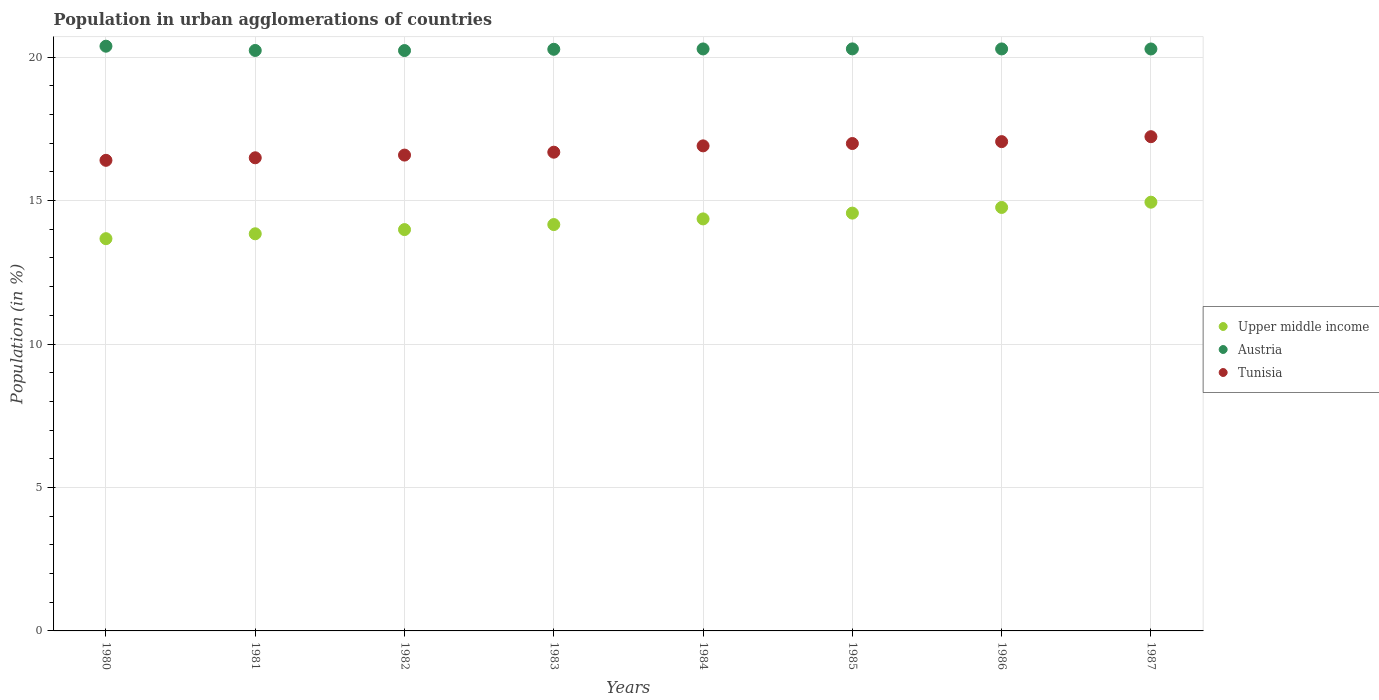Is the number of dotlines equal to the number of legend labels?
Provide a succinct answer. Yes. What is the percentage of population in urban agglomerations in Tunisia in 1986?
Ensure brevity in your answer.  17.06. Across all years, what is the maximum percentage of population in urban agglomerations in Upper middle income?
Provide a succinct answer. 14.95. Across all years, what is the minimum percentage of population in urban agglomerations in Austria?
Your response must be concise. 20.23. In which year was the percentage of population in urban agglomerations in Upper middle income minimum?
Offer a terse response. 1980. What is the total percentage of population in urban agglomerations in Upper middle income in the graph?
Provide a short and direct response. 114.31. What is the difference between the percentage of population in urban agglomerations in Tunisia in 1985 and that in 1986?
Make the answer very short. -0.07. What is the difference between the percentage of population in urban agglomerations in Tunisia in 1985 and the percentage of population in urban agglomerations in Upper middle income in 1981?
Provide a succinct answer. 3.15. What is the average percentage of population in urban agglomerations in Tunisia per year?
Give a very brief answer. 16.79. In the year 1985, what is the difference between the percentage of population in urban agglomerations in Austria and percentage of population in urban agglomerations in Tunisia?
Ensure brevity in your answer.  3.3. What is the ratio of the percentage of population in urban agglomerations in Tunisia in 1981 to that in 1985?
Your answer should be compact. 0.97. What is the difference between the highest and the second highest percentage of population in urban agglomerations in Austria?
Make the answer very short. 0.09. What is the difference between the highest and the lowest percentage of population in urban agglomerations in Upper middle income?
Make the answer very short. 1.27. Does the percentage of population in urban agglomerations in Tunisia monotonically increase over the years?
Provide a short and direct response. Yes. How many dotlines are there?
Offer a very short reply. 3. How many years are there in the graph?
Provide a succinct answer. 8. Are the values on the major ticks of Y-axis written in scientific E-notation?
Provide a short and direct response. No. Does the graph contain grids?
Give a very brief answer. Yes. How are the legend labels stacked?
Offer a terse response. Vertical. What is the title of the graph?
Provide a succinct answer. Population in urban agglomerations of countries. What is the Population (in %) in Upper middle income in 1980?
Your answer should be compact. 13.67. What is the Population (in %) of Austria in 1980?
Your response must be concise. 20.38. What is the Population (in %) in Tunisia in 1980?
Make the answer very short. 16.4. What is the Population (in %) of Upper middle income in 1981?
Make the answer very short. 13.84. What is the Population (in %) in Austria in 1981?
Offer a terse response. 20.23. What is the Population (in %) of Tunisia in 1981?
Offer a very short reply. 16.49. What is the Population (in %) in Upper middle income in 1982?
Offer a terse response. 13.99. What is the Population (in %) of Austria in 1982?
Your answer should be very brief. 20.23. What is the Population (in %) of Tunisia in 1982?
Provide a succinct answer. 16.59. What is the Population (in %) in Upper middle income in 1983?
Your response must be concise. 14.17. What is the Population (in %) of Austria in 1983?
Make the answer very short. 20.27. What is the Population (in %) in Tunisia in 1983?
Offer a very short reply. 16.69. What is the Population (in %) in Upper middle income in 1984?
Your response must be concise. 14.36. What is the Population (in %) of Austria in 1984?
Your response must be concise. 20.29. What is the Population (in %) of Tunisia in 1984?
Keep it short and to the point. 16.91. What is the Population (in %) of Upper middle income in 1985?
Your answer should be very brief. 14.56. What is the Population (in %) of Austria in 1985?
Provide a succinct answer. 20.29. What is the Population (in %) in Tunisia in 1985?
Provide a short and direct response. 16.99. What is the Population (in %) in Upper middle income in 1986?
Your answer should be very brief. 14.76. What is the Population (in %) in Austria in 1986?
Your response must be concise. 20.29. What is the Population (in %) of Tunisia in 1986?
Offer a very short reply. 17.06. What is the Population (in %) of Upper middle income in 1987?
Offer a very short reply. 14.95. What is the Population (in %) in Austria in 1987?
Provide a succinct answer. 20.29. What is the Population (in %) of Tunisia in 1987?
Provide a succinct answer. 17.23. Across all years, what is the maximum Population (in %) of Upper middle income?
Offer a terse response. 14.95. Across all years, what is the maximum Population (in %) of Austria?
Keep it short and to the point. 20.38. Across all years, what is the maximum Population (in %) of Tunisia?
Your response must be concise. 17.23. Across all years, what is the minimum Population (in %) of Upper middle income?
Keep it short and to the point. 13.67. Across all years, what is the minimum Population (in %) in Austria?
Ensure brevity in your answer.  20.23. Across all years, what is the minimum Population (in %) in Tunisia?
Your answer should be very brief. 16.4. What is the total Population (in %) of Upper middle income in the graph?
Your answer should be very brief. 114.31. What is the total Population (in %) of Austria in the graph?
Provide a short and direct response. 162.27. What is the total Population (in %) in Tunisia in the graph?
Your answer should be compact. 134.35. What is the difference between the Population (in %) in Upper middle income in 1980 and that in 1981?
Offer a very short reply. -0.17. What is the difference between the Population (in %) in Austria in 1980 and that in 1981?
Make the answer very short. 0.15. What is the difference between the Population (in %) in Tunisia in 1980 and that in 1981?
Provide a short and direct response. -0.09. What is the difference between the Population (in %) in Upper middle income in 1980 and that in 1982?
Provide a succinct answer. -0.32. What is the difference between the Population (in %) in Austria in 1980 and that in 1982?
Offer a very short reply. 0.15. What is the difference between the Population (in %) in Tunisia in 1980 and that in 1982?
Give a very brief answer. -0.18. What is the difference between the Population (in %) in Upper middle income in 1980 and that in 1983?
Keep it short and to the point. -0.49. What is the difference between the Population (in %) of Austria in 1980 and that in 1983?
Ensure brevity in your answer.  0.11. What is the difference between the Population (in %) of Tunisia in 1980 and that in 1983?
Your answer should be compact. -0.28. What is the difference between the Population (in %) in Upper middle income in 1980 and that in 1984?
Your answer should be compact. -0.69. What is the difference between the Population (in %) in Austria in 1980 and that in 1984?
Offer a terse response. 0.1. What is the difference between the Population (in %) of Tunisia in 1980 and that in 1984?
Keep it short and to the point. -0.5. What is the difference between the Population (in %) of Upper middle income in 1980 and that in 1985?
Your answer should be compact. -0.89. What is the difference between the Population (in %) of Austria in 1980 and that in 1985?
Your answer should be compact. 0.09. What is the difference between the Population (in %) in Tunisia in 1980 and that in 1985?
Offer a terse response. -0.59. What is the difference between the Population (in %) of Upper middle income in 1980 and that in 1986?
Offer a very short reply. -1.09. What is the difference between the Population (in %) of Austria in 1980 and that in 1986?
Your response must be concise. 0.1. What is the difference between the Population (in %) in Tunisia in 1980 and that in 1986?
Offer a terse response. -0.65. What is the difference between the Population (in %) in Upper middle income in 1980 and that in 1987?
Ensure brevity in your answer.  -1.27. What is the difference between the Population (in %) of Austria in 1980 and that in 1987?
Your answer should be very brief. 0.1. What is the difference between the Population (in %) in Tunisia in 1980 and that in 1987?
Give a very brief answer. -0.82. What is the difference between the Population (in %) of Upper middle income in 1981 and that in 1982?
Your answer should be very brief. -0.15. What is the difference between the Population (in %) in Austria in 1981 and that in 1982?
Keep it short and to the point. 0. What is the difference between the Population (in %) of Tunisia in 1981 and that in 1982?
Give a very brief answer. -0.09. What is the difference between the Population (in %) of Upper middle income in 1981 and that in 1983?
Ensure brevity in your answer.  -0.32. What is the difference between the Population (in %) in Austria in 1981 and that in 1983?
Provide a short and direct response. -0.04. What is the difference between the Population (in %) in Tunisia in 1981 and that in 1983?
Your answer should be compact. -0.2. What is the difference between the Population (in %) of Upper middle income in 1981 and that in 1984?
Offer a very short reply. -0.52. What is the difference between the Population (in %) of Austria in 1981 and that in 1984?
Provide a short and direct response. -0.05. What is the difference between the Population (in %) in Tunisia in 1981 and that in 1984?
Provide a short and direct response. -0.42. What is the difference between the Population (in %) in Upper middle income in 1981 and that in 1985?
Offer a very short reply. -0.72. What is the difference between the Population (in %) in Austria in 1981 and that in 1985?
Ensure brevity in your answer.  -0.05. What is the difference between the Population (in %) in Tunisia in 1981 and that in 1985?
Provide a succinct answer. -0.5. What is the difference between the Population (in %) of Upper middle income in 1981 and that in 1986?
Provide a short and direct response. -0.92. What is the difference between the Population (in %) of Austria in 1981 and that in 1986?
Your response must be concise. -0.05. What is the difference between the Population (in %) in Tunisia in 1981 and that in 1986?
Offer a terse response. -0.56. What is the difference between the Population (in %) in Upper middle income in 1981 and that in 1987?
Ensure brevity in your answer.  -1.1. What is the difference between the Population (in %) in Austria in 1981 and that in 1987?
Give a very brief answer. -0.05. What is the difference between the Population (in %) of Tunisia in 1981 and that in 1987?
Keep it short and to the point. -0.74. What is the difference between the Population (in %) of Upper middle income in 1982 and that in 1983?
Make the answer very short. -0.18. What is the difference between the Population (in %) of Austria in 1982 and that in 1983?
Offer a very short reply. -0.04. What is the difference between the Population (in %) of Tunisia in 1982 and that in 1983?
Keep it short and to the point. -0.1. What is the difference between the Population (in %) of Upper middle income in 1982 and that in 1984?
Ensure brevity in your answer.  -0.37. What is the difference between the Population (in %) of Austria in 1982 and that in 1984?
Give a very brief answer. -0.06. What is the difference between the Population (in %) in Tunisia in 1982 and that in 1984?
Keep it short and to the point. -0.32. What is the difference between the Population (in %) of Upper middle income in 1982 and that in 1985?
Provide a short and direct response. -0.57. What is the difference between the Population (in %) in Austria in 1982 and that in 1985?
Provide a succinct answer. -0.06. What is the difference between the Population (in %) of Tunisia in 1982 and that in 1985?
Make the answer very short. -0.4. What is the difference between the Population (in %) in Upper middle income in 1982 and that in 1986?
Make the answer very short. -0.77. What is the difference between the Population (in %) of Austria in 1982 and that in 1986?
Ensure brevity in your answer.  -0.06. What is the difference between the Population (in %) in Tunisia in 1982 and that in 1986?
Offer a very short reply. -0.47. What is the difference between the Population (in %) in Upper middle income in 1982 and that in 1987?
Make the answer very short. -0.96. What is the difference between the Population (in %) of Austria in 1982 and that in 1987?
Ensure brevity in your answer.  -0.05. What is the difference between the Population (in %) in Tunisia in 1982 and that in 1987?
Give a very brief answer. -0.64. What is the difference between the Population (in %) of Upper middle income in 1983 and that in 1984?
Offer a terse response. -0.2. What is the difference between the Population (in %) in Austria in 1983 and that in 1984?
Provide a succinct answer. -0.01. What is the difference between the Population (in %) in Tunisia in 1983 and that in 1984?
Keep it short and to the point. -0.22. What is the difference between the Population (in %) of Upper middle income in 1983 and that in 1985?
Ensure brevity in your answer.  -0.4. What is the difference between the Population (in %) in Austria in 1983 and that in 1985?
Give a very brief answer. -0.01. What is the difference between the Population (in %) in Tunisia in 1983 and that in 1985?
Offer a very short reply. -0.3. What is the difference between the Population (in %) in Upper middle income in 1983 and that in 1986?
Give a very brief answer. -0.6. What is the difference between the Population (in %) in Austria in 1983 and that in 1986?
Your answer should be compact. -0.01. What is the difference between the Population (in %) in Tunisia in 1983 and that in 1986?
Give a very brief answer. -0.37. What is the difference between the Population (in %) in Upper middle income in 1983 and that in 1987?
Provide a short and direct response. -0.78. What is the difference between the Population (in %) of Austria in 1983 and that in 1987?
Ensure brevity in your answer.  -0.01. What is the difference between the Population (in %) in Tunisia in 1983 and that in 1987?
Make the answer very short. -0.54. What is the difference between the Population (in %) in Upper middle income in 1984 and that in 1985?
Your answer should be compact. -0.2. What is the difference between the Population (in %) in Austria in 1984 and that in 1985?
Offer a terse response. -0. What is the difference between the Population (in %) of Tunisia in 1984 and that in 1985?
Make the answer very short. -0.08. What is the difference between the Population (in %) of Upper middle income in 1984 and that in 1986?
Keep it short and to the point. -0.4. What is the difference between the Population (in %) of Austria in 1984 and that in 1986?
Your answer should be very brief. -0. What is the difference between the Population (in %) in Tunisia in 1984 and that in 1986?
Provide a succinct answer. -0.15. What is the difference between the Population (in %) of Upper middle income in 1984 and that in 1987?
Offer a very short reply. -0.58. What is the difference between the Population (in %) of Austria in 1984 and that in 1987?
Give a very brief answer. 0. What is the difference between the Population (in %) of Tunisia in 1984 and that in 1987?
Provide a succinct answer. -0.32. What is the difference between the Population (in %) in Upper middle income in 1985 and that in 1986?
Offer a very short reply. -0.2. What is the difference between the Population (in %) of Austria in 1985 and that in 1986?
Keep it short and to the point. 0. What is the difference between the Population (in %) in Tunisia in 1985 and that in 1986?
Your answer should be very brief. -0.07. What is the difference between the Population (in %) in Upper middle income in 1985 and that in 1987?
Give a very brief answer. -0.38. What is the difference between the Population (in %) in Austria in 1985 and that in 1987?
Make the answer very short. 0. What is the difference between the Population (in %) of Tunisia in 1985 and that in 1987?
Keep it short and to the point. -0.24. What is the difference between the Population (in %) in Upper middle income in 1986 and that in 1987?
Provide a short and direct response. -0.18. What is the difference between the Population (in %) in Austria in 1986 and that in 1987?
Provide a succinct answer. 0. What is the difference between the Population (in %) of Tunisia in 1986 and that in 1987?
Provide a short and direct response. -0.17. What is the difference between the Population (in %) of Upper middle income in 1980 and the Population (in %) of Austria in 1981?
Provide a short and direct response. -6.56. What is the difference between the Population (in %) of Upper middle income in 1980 and the Population (in %) of Tunisia in 1981?
Your answer should be compact. -2.82. What is the difference between the Population (in %) in Austria in 1980 and the Population (in %) in Tunisia in 1981?
Provide a short and direct response. 3.89. What is the difference between the Population (in %) in Upper middle income in 1980 and the Population (in %) in Austria in 1982?
Your answer should be compact. -6.56. What is the difference between the Population (in %) in Upper middle income in 1980 and the Population (in %) in Tunisia in 1982?
Give a very brief answer. -2.91. What is the difference between the Population (in %) in Austria in 1980 and the Population (in %) in Tunisia in 1982?
Provide a succinct answer. 3.8. What is the difference between the Population (in %) in Upper middle income in 1980 and the Population (in %) in Austria in 1983?
Offer a terse response. -6.6. What is the difference between the Population (in %) in Upper middle income in 1980 and the Population (in %) in Tunisia in 1983?
Keep it short and to the point. -3.01. What is the difference between the Population (in %) of Austria in 1980 and the Population (in %) of Tunisia in 1983?
Provide a succinct answer. 3.69. What is the difference between the Population (in %) of Upper middle income in 1980 and the Population (in %) of Austria in 1984?
Your answer should be very brief. -6.61. What is the difference between the Population (in %) of Upper middle income in 1980 and the Population (in %) of Tunisia in 1984?
Offer a very short reply. -3.23. What is the difference between the Population (in %) in Austria in 1980 and the Population (in %) in Tunisia in 1984?
Your answer should be very brief. 3.47. What is the difference between the Population (in %) of Upper middle income in 1980 and the Population (in %) of Austria in 1985?
Give a very brief answer. -6.62. What is the difference between the Population (in %) of Upper middle income in 1980 and the Population (in %) of Tunisia in 1985?
Your response must be concise. -3.32. What is the difference between the Population (in %) in Austria in 1980 and the Population (in %) in Tunisia in 1985?
Your answer should be compact. 3.39. What is the difference between the Population (in %) of Upper middle income in 1980 and the Population (in %) of Austria in 1986?
Your answer should be very brief. -6.61. What is the difference between the Population (in %) in Upper middle income in 1980 and the Population (in %) in Tunisia in 1986?
Offer a terse response. -3.38. What is the difference between the Population (in %) in Austria in 1980 and the Population (in %) in Tunisia in 1986?
Provide a succinct answer. 3.33. What is the difference between the Population (in %) of Upper middle income in 1980 and the Population (in %) of Austria in 1987?
Give a very brief answer. -6.61. What is the difference between the Population (in %) of Upper middle income in 1980 and the Population (in %) of Tunisia in 1987?
Provide a short and direct response. -3.56. What is the difference between the Population (in %) of Austria in 1980 and the Population (in %) of Tunisia in 1987?
Offer a very short reply. 3.15. What is the difference between the Population (in %) of Upper middle income in 1981 and the Population (in %) of Austria in 1982?
Offer a very short reply. -6.39. What is the difference between the Population (in %) of Upper middle income in 1981 and the Population (in %) of Tunisia in 1982?
Provide a short and direct response. -2.74. What is the difference between the Population (in %) of Austria in 1981 and the Population (in %) of Tunisia in 1982?
Your answer should be compact. 3.65. What is the difference between the Population (in %) in Upper middle income in 1981 and the Population (in %) in Austria in 1983?
Give a very brief answer. -6.43. What is the difference between the Population (in %) of Upper middle income in 1981 and the Population (in %) of Tunisia in 1983?
Give a very brief answer. -2.84. What is the difference between the Population (in %) of Austria in 1981 and the Population (in %) of Tunisia in 1983?
Your response must be concise. 3.55. What is the difference between the Population (in %) of Upper middle income in 1981 and the Population (in %) of Austria in 1984?
Ensure brevity in your answer.  -6.44. What is the difference between the Population (in %) in Upper middle income in 1981 and the Population (in %) in Tunisia in 1984?
Provide a succinct answer. -3.06. What is the difference between the Population (in %) of Austria in 1981 and the Population (in %) of Tunisia in 1984?
Keep it short and to the point. 3.33. What is the difference between the Population (in %) in Upper middle income in 1981 and the Population (in %) in Austria in 1985?
Your response must be concise. -6.45. What is the difference between the Population (in %) of Upper middle income in 1981 and the Population (in %) of Tunisia in 1985?
Offer a terse response. -3.15. What is the difference between the Population (in %) of Austria in 1981 and the Population (in %) of Tunisia in 1985?
Your answer should be compact. 3.24. What is the difference between the Population (in %) in Upper middle income in 1981 and the Population (in %) in Austria in 1986?
Keep it short and to the point. -6.44. What is the difference between the Population (in %) of Upper middle income in 1981 and the Population (in %) of Tunisia in 1986?
Offer a terse response. -3.21. What is the difference between the Population (in %) of Austria in 1981 and the Population (in %) of Tunisia in 1986?
Your answer should be very brief. 3.18. What is the difference between the Population (in %) in Upper middle income in 1981 and the Population (in %) in Austria in 1987?
Make the answer very short. -6.44. What is the difference between the Population (in %) in Upper middle income in 1981 and the Population (in %) in Tunisia in 1987?
Your response must be concise. -3.38. What is the difference between the Population (in %) of Austria in 1981 and the Population (in %) of Tunisia in 1987?
Keep it short and to the point. 3.01. What is the difference between the Population (in %) in Upper middle income in 1982 and the Population (in %) in Austria in 1983?
Offer a terse response. -6.28. What is the difference between the Population (in %) in Upper middle income in 1982 and the Population (in %) in Tunisia in 1983?
Your answer should be compact. -2.7. What is the difference between the Population (in %) in Austria in 1982 and the Population (in %) in Tunisia in 1983?
Your answer should be compact. 3.54. What is the difference between the Population (in %) in Upper middle income in 1982 and the Population (in %) in Austria in 1984?
Give a very brief answer. -6.3. What is the difference between the Population (in %) in Upper middle income in 1982 and the Population (in %) in Tunisia in 1984?
Make the answer very short. -2.92. What is the difference between the Population (in %) of Austria in 1982 and the Population (in %) of Tunisia in 1984?
Your response must be concise. 3.32. What is the difference between the Population (in %) in Upper middle income in 1982 and the Population (in %) in Austria in 1985?
Provide a short and direct response. -6.3. What is the difference between the Population (in %) of Upper middle income in 1982 and the Population (in %) of Tunisia in 1985?
Ensure brevity in your answer.  -3. What is the difference between the Population (in %) of Austria in 1982 and the Population (in %) of Tunisia in 1985?
Provide a short and direct response. 3.24. What is the difference between the Population (in %) in Upper middle income in 1982 and the Population (in %) in Austria in 1986?
Offer a very short reply. -6.3. What is the difference between the Population (in %) of Upper middle income in 1982 and the Population (in %) of Tunisia in 1986?
Your answer should be very brief. -3.07. What is the difference between the Population (in %) of Austria in 1982 and the Population (in %) of Tunisia in 1986?
Your answer should be compact. 3.17. What is the difference between the Population (in %) in Upper middle income in 1982 and the Population (in %) in Austria in 1987?
Your answer should be very brief. -6.3. What is the difference between the Population (in %) of Upper middle income in 1982 and the Population (in %) of Tunisia in 1987?
Your answer should be compact. -3.24. What is the difference between the Population (in %) of Austria in 1982 and the Population (in %) of Tunisia in 1987?
Offer a very short reply. 3. What is the difference between the Population (in %) in Upper middle income in 1983 and the Population (in %) in Austria in 1984?
Your answer should be compact. -6.12. What is the difference between the Population (in %) in Upper middle income in 1983 and the Population (in %) in Tunisia in 1984?
Your answer should be compact. -2.74. What is the difference between the Population (in %) of Austria in 1983 and the Population (in %) of Tunisia in 1984?
Make the answer very short. 3.37. What is the difference between the Population (in %) in Upper middle income in 1983 and the Population (in %) in Austria in 1985?
Your answer should be very brief. -6.12. What is the difference between the Population (in %) in Upper middle income in 1983 and the Population (in %) in Tunisia in 1985?
Your response must be concise. -2.83. What is the difference between the Population (in %) of Austria in 1983 and the Population (in %) of Tunisia in 1985?
Keep it short and to the point. 3.28. What is the difference between the Population (in %) in Upper middle income in 1983 and the Population (in %) in Austria in 1986?
Keep it short and to the point. -6.12. What is the difference between the Population (in %) of Upper middle income in 1983 and the Population (in %) of Tunisia in 1986?
Offer a terse response. -2.89. What is the difference between the Population (in %) in Austria in 1983 and the Population (in %) in Tunisia in 1986?
Offer a terse response. 3.22. What is the difference between the Population (in %) in Upper middle income in 1983 and the Population (in %) in Austria in 1987?
Your answer should be very brief. -6.12. What is the difference between the Population (in %) of Upper middle income in 1983 and the Population (in %) of Tunisia in 1987?
Give a very brief answer. -3.06. What is the difference between the Population (in %) in Austria in 1983 and the Population (in %) in Tunisia in 1987?
Provide a short and direct response. 3.05. What is the difference between the Population (in %) of Upper middle income in 1984 and the Population (in %) of Austria in 1985?
Keep it short and to the point. -5.93. What is the difference between the Population (in %) in Upper middle income in 1984 and the Population (in %) in Tunisia in 1985?
Your answer should be very brief. -2.63. What is the difference between the Population (in %) of Austria in 1984 and the Population (in %) of Tunisia in 1985?
Provide a succinct answer. 3.3. What is the difference between the Population (in %) of Upper middle income in 1984 and the Population (in %) of Austria in 1986?
Provide a succinct answer. -5.92. What is the difference between the Population (in %) in Upper middle income in 1984 and the Population (in %) in Tunisia in 1986?
Your answer should be very brief. -2.69. What is the difference between the Population (in %) of Austria in 1984 and the Population (in %) of Tunisia in 1986?
Give a very brief answer. 3.23. What is the difference between the Population (in %) of Upper middle income in 1984 and the Population (in %) of Austria in 1987?
Make the answer very short. -5.92. What is the difference between the Population (in %) of Upper middle income in 1984 and the Population (in %) of Tunisia in 1987?
Make the answer very short. -2.87. What is the difference between the Population (in %) of Austria in 1984 and the Population (in %) of Tunisia in 1987?
Offer a very short reply. 3.06. What is the difference between the Population (in %) of Upper middle income in 1985 and the Population (in %) of Austria in 1986?
Make the answer very short. -5.72. What is the difference between the Population (in %) of Upper middle income in 1985 and the Population (in %) of Tunisia in 1986?
Offer a very short reply. -2.49. What is the difference between the Population (in %) of Austria in 1985 and the Population (in %) of Tunisia in 1986?
Make the answer very short. 3.23. What is the difference between the Population (in %) in Upper middle income in 1985 and the Population (in %) in Austria in 1987?
Your answer should be very brief. -5.72. What is the difference between the Population (in %) of Upper middle income in 1985 and the Population (in %) of Tunisia in 1987?
Provide a succinct answer. -2.66. What is the difference between the Population (in %) in Austria in 1985 and the Population (in %) in Tunisia in 1987?
Make the answer very short. 3.06. What is the difference between the Population (in %) in Upper middle income in 1986 and the Population (in %) in Austria in 1987?
Ensure brevity in your answer.  -5.52. What is the difference between the Population (in %) of Upper middle income in 1986 and the Population (in %) of Tunisia in 1987?
Offer a terse response. -2.47. What is the difference between the Population (in %) in Austria in 1986 and the Population (in %) in Tunisia in 1987?
Offer a very short reply. 3.06. What is the average Population (in %) of Upper middle income per year?
Offer a terse response. 14.29. What is the average Population (in %) of Austria per year?
Provide a short and direct response. 20.28. What is the average Population (in %) of Tunisia per year?
Offer a terse response. 16.79. In the year 1980, what is the difference between the Population (in %) in Upper middle income and Population (in %) in Austria?
Your answer should be compact. -6.71. In the year 1980, what is the difference between the Population (in %) of Upper middle income and Population (in %) of Tunisia?
Keep it short and to the point. -2.73. In the year 1980, what is the difference between the Population (in %) of Austria and Population (in %) of Tunisia?
Provide a short and direct response. 3.98. In the year 1981, what is the difference between the Population (in %) in Upper middle income and Population (in %) in Austria?
Your answer should be very brief. -6.39. In the year 1981, what is the difference between the Population (in %) of Upper middle income and Population (in %) of Tunisia?
Give a very brief answer. -2.65. In the year 1981, what is the difference between the Population (in %) in Austria and Population (in %) in Tunisia?
Give a very brief answer. 3.74. In the year 1982, what is the difference between the Population (in %) in Upper middle income and Population (in %) in Austria?
Make the answer very short. -6.24. In the year 1982, what is the difference between the Population (in %) in Upper middle income and Population (in %) in Tunisia?
Provide a succinct answer. -2.6. In the year 1982, what is the difference between the Population (in %) in Austria and Population (in %) in Tunisia?
Keep it short and to the point. 3.64. In the year 1983, what is the difference between the Population (in %) in Upper middle income and Population (in %) in Austria?
Give a very brief answer. -6.11. In the year 1983, what is the difference between the Population (in %) in Upper middle income and Population (in %) in Tunisia?
Make the answer very short. -2.52. In the year 1983, what is the difference between the Population (in %) of Austria and Population (in %) of Tunisia?
Your response must be concise. 3.59. In the year 1984, what is the difference between the Population (in %) of Upper middle income and Population (in %) of Austria?
Ensure brevity in your answer.  -5.92. In the year 1984, what is the difference between the Population (in %) in Upper middle income and Population (in %) in Tunisia?
Ensure brevity in your answer.  -2.55. In the year 1984, what is the difference between the Population (in %) in Austria and Population (in %) in Tunisia?
Give a very brief answer. 3.38. In the year 1985, what is the difference between the Population (in %) in Upper middle income and Population (in %) in Austria?
Give a very brief answer. -5.72. In the year 1985, what is the difference between the Population (in %) in Upper middle income and Population (in %) in Tunisia?
Offer a terse response. -2.43. In the year 1985, what is the difference between the Population (in %) in Austria and Population (in %) in Tunisia?
Provide a short and direct response. 3.3. In the year 1986, what is the difference between the Population (in %) of Upper middle income and Population (in %) of Austria?
Provide a short and direct response. -5.53. In the year 1986, what is the difference between the Population (in %) of Upper middle income and Population (in %) of Tunisia?
Your response must be concise. -2.29. In the year 1986, what is the difference between the Population (in %) of Austria and Population (in %) of Tunisia?
Ensure brevity in your answer.  3.23. In the year 1987, what is the difference between the Population (in %) of Upper middle income and Population (in %) of Austria?
Provide a short and direct response. -5.34. In the year 1987, what is the difference between the Population (in %) of Upper middle income and Population (in %) of Tunisia?
Offer a very short reply. -2.28. In the year 1987, what is the difference between the Population (in %) in Austria and Population (in %) in Tunisia?
Offer a terse response. 3.06. What is the ratio of the Population (in %) in Upper middle income in 1980 to that in 1981?
Make the answer very short. 0.99. What is the ratio of the Population (in %) in Austria in 1980 to that in 1981?
Your answer should be very brief. 1.01. What is the ratio of the Population (in %) in Upper middle income in 1980 to that in 1982?
Provide a short and direct response. 0.98. What is the ratio of the Population (in %) in Austria in 1980 to that in 1982?
Your answer should be very brief. 1.01. What is the ratio of the Population (in %) in Tunisia in 1980 to that in 1982?
Make the answer very short. 0.99. What is the ratio of the Population (in %) in Upper middle income in 1980 to that in 1983?
Your answer should be very brief. 0.97. What is the ratio of the Population (in %) of Austria in 1980 to that in 1983?
Offer a terse response. 1.01. What is the ratio of the Population (in %) in Tunisia in 1980 to that in 1983?
Ensure brevity in your answer.  0.98. What is the ratio of the Population (in %) of Upper middle income in 1980 to that in 1984?
Provide a short and direct response. 0.95. What is the ratio of the Population (in %) of Tunisia in 1980 to that in 1984?
Offer a terse response. 0.97. What is the ratio of the Population (in %) of Upper middle income in 1980 to that in 1985?
Ensure brevity in your answer.  0.94. What is the ratio of the Population (in %) of Tunisia in 1980 to that in 1985?
Provide a succinct answer. 0.97. What is the ratio of the Population (in %) of Upper middle income in 1980 to that in 1986?
Offer a very short reply. 0.93. What is the ratio of the Population (in %) of Austria in 1980 to that in 1986?
Your response must be concise. 1. What is the ratio of the Population (in %) in Tunisia in 1980 to that in 1986?
Keep it short and to the point. 0.96. What is the ratio of the Population (in %) of Upper middle income in 1980 to that in 1987?
Offer a very short reply. 0.91. What is the ratio of the Population (in %) in Tunisia in 1980 to that in 1987?
Offer a very short reply. 0.95. What is the ratio of the Population (in %) of Austria in 1981 to that in 1982?
Offer a very short reply. 1. What is the ratio of the Population (in %) of Upper middle income in 1981 to that in 1983?
Provide a short and direct response. 0.98. What is the ratio of the Population (in %) in Tunisia in 1981 to that in 1983?
Ensure brevity in your answer.  0.99. What is the ratio of the Population (in %) in Upper middle income in 1981 to that in 1984?
Your answer should be very brief. 0.96. What is the ratio of the Population (in %) in Tunisia in 1981 to that in 1984?
Make the answer very short. 0.98. What is the ratio of the Population (in %) in Upper middle income in 1981 to that in 1985?
Give a very brief answer. 0.95. What is the ratio of the Population (in %) of Austria in 1981 to that in 1985?
Provide a short and direct response. 1. What is the ratio of the Population (in %) of Tunisia in 1981 to that in 1985?
Provide a succinct answer. 0.97. What is the ratio of the Population (in %) of Upper middle income in 1981 to that in 1986?
Give a very brief answer. 0.94. What is the ratio of the Population (in %) of Tunisia in 1981 to that in 1986?
Your answer should be compact. 0.97. What is the ratio of the Population (in %) in Upper middle income in 1981 to that in 1987?
Offer a very short reply. 0.93. What is the ratio of the Population (in %) in Tunisia in 1981 to that in 1987?
Make the answer very short. 0.96. What is the ratio of the Population (in %) of Upper middle income in 1982 to that in 1983?
Offer a terse response. 0.99. What is the ratio of the Population (in %) in Upper middle income in 1982 to that in 1984?
Your response must be concise. 0.97. What is the ratio of the Population (in %) in Tunisia in 1982 to that in 1984?
Ensure brevity in your answer.  0.98. What is the ratio of the Population (in %) of Upper middle income in 1982 to that in 1985?
Your response must be concise. 0.96. What is the ratio of the Population (in %) in Tunisia in 1982 to that in 1985?
Make the answer very short. 0.98. What is the ratio of the Population (in %) in Upper middle income in 1982 to that in 1986?
Give a very brief answer. 0.95. What is the ratio of the Population (in %) of Tunisia in 1982 to that in 1986?
Offer a very short reply. 0.97. What is the ratio of the Population (in %) of Upper middle income in 1982 to that in 1987?
Your response must be concise. 0.94. What is the ratio of the Population (in %) of Tunisia in 1982 to that in 1987?
Keep it short and to the point. 0.96. What is the ratio of the Population (in %) of Upper middle income in 1983 to that in 1984?
Your answer should be very brief. 0.99. What is the ratio of the Population (in %) in Upper middle income in 1983 to that in 1985?
Offer a terse response. 0.97. What is the ratio of the Population (in %) of Austria in 1983 to that in 1985?
Provide a succinct answer. 1. What is the ratio of the Population (in %) of Tunisia in 1983 to that in 1985?
Offer a terse response. 0.98. What is the ratio of the Population (in %) of Upper middle income in 1983 to that in 1986?
Your answer should be compact. 0.96. What is the ratio of the Population (in %) of Austria in 1983 to that in 1986?
Give a very brief answer. 1. What is the ratio of the Population (in %) of Tunisia in 1983 to that in 1986?
Give a very brief answer. 0.98. What is the ratio of the Population (in %) in Upper middle income in 1983 to that in 1987?
Give a very brief answer. 0.95. What is the ratio of the Population (in %) in Tunisia in 1983 to that in 1987?
Your answer should be compact. 0.97. What is the ratio of the Population (in %) of Upper middle income in 1984 to that in 1985?
Keep it short and to the point. 0.99. What is the ratio of the Population (in %) of Tunisia in 1984 to that in 1985?
Offer a terse response. 1. What is the ratio of the Population (in %) of Upper middle income in 1984 to that in 1986?
Provide a short and direct response. 0.97. What is the ratio of the Population (in %) in Austria in 1984 to that in 1986?
Offer a very short reply. 1. What is the ratio of the Population (in %) of Austria in 1984 to that in 1987?
Provide a short and direct response. 1. What is the ratio of the Population (in %) in Tunisia in 1984 to that in 1987?
Provide a short and direct response. 0.98. What is the ratio of the Population (in %) of Upper middle income in 1985 to that in 1986?
Offer a very short reply. 0.99. What is the ratio of the Population (in %) in Austria in 1985 to that in 1986?
Give a very brief answer. 1. What is the ratio of the Population (in %) in Tunisia in 1985 to that in 1986?
Your answer should be very brief. 1. What is the ratio of the Population (in %) in Upper middle income in 1985 to that in 1987?
Your response must be concise. 0.97. What is the ratio of the Population (in %) in Tunisia in 1985 to that in 1987?
Give a very brief answer. 0.99. What is the ratio of the Population (in %) of Upper middle income in 1986 to that in 1987?
Your response must be concise. 0.99. What is the ratio of the Population (in %) in Tunisia in 1986 to that in 1987?
Offer a terse response. 0.99. What is the difference between the highest and the second highest Population (in %) in Upper middle income?
Give a very brief answer. 0.18. What is the difference between the highest and the second highest Population (in %) of Austria?
Ensure brevity in your answer.  0.09. What is the difference between the highest and the second highest Population (in %) in Tunisia?
Give a very brief answer. 0.17. What is the difference between the highest and the lowest Population (in %) of Upper middle income?
Your answer should be compact. 1.27. What is the difference between the highest and the lowest Population (in %) in Austria?
Your answer should be compact. 0.15. What is the difference between the highest and the lowest Population (in %) in Tunisia?
Your answer should be compact. 0.82. 